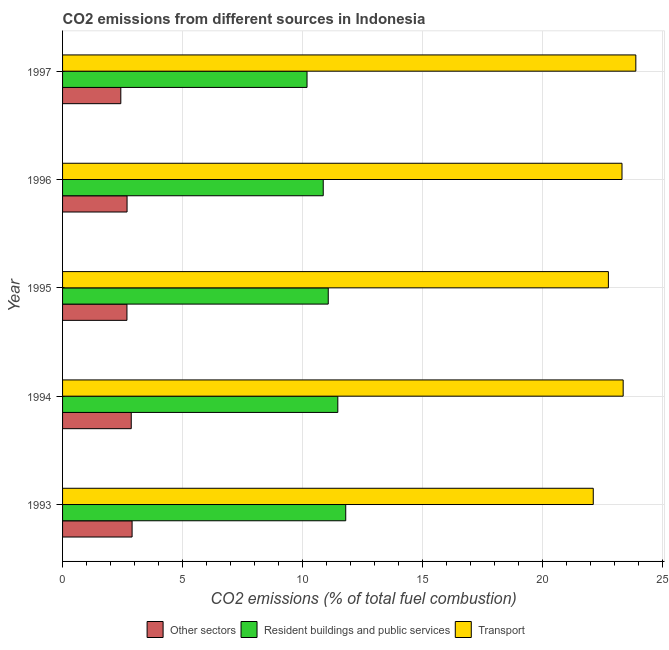How many different coloured bars are there?
Keep it short and to the point. 3. Are the number of bars per tick equal to the number of legend labels?
Provide a short and direct response. Yes. How many bars are there on the 2nd tick from the top?
Provide a short and direct response. 3. How many bars are there on the 4th tick from the bottom?
Offer a very short reply. 3. What is the label of the 5th group of bars from the top?
Offer a very short reply. 1993. What is the percentage of co2 emissions from resident buildings and public services in 1995?
Your response must be concise. 11.07. Across all years, what is the maximum percentage of co2 emissions from transport?
Keep it short and to the point. 23.88. Across all years, what is the minimum percentage of co2 emissions from transport?
Offer a very short reply. 22.11. What is the total percentage of co2 emissions from other sectors in the graph?
Keep it short and to the point. 13.55. What is the difference between the percentage of co2 emissions from transport in 1993 and that in 1995?
Give a very brief answer. -0.63. What is the difference between the percentage of co2 emissions from transport in 1994 and the percentage of co2 emissions from other sectors in 1996?
Offer a terse response. 20.67. What is the average percentage of co2 emissions from transport per year?
Offer a very short reply. 23.08. In the year 1995, what is the difference between the percentage of co2 emissions from resident buildings and public services and percentage of co2 emissions from transport?
Offer a terse response. -11.67. In how many years, is the percentage of co2 emissions from transport greater than 15 %?
Give a very brief answer. 5. What is the ratio of the percentage of co2 emissions from other sectors in 1995 to that in 1996?
Give a very brief answer. 1. Is the difference between the percentage of co2 emissions from transport in 1995 and 1997 greater than the difference between the percentage of co2 emissions from other sectors in 1995 and 1997?
Offer a very short reply. No. What is the difference between the highest and the second highest percentage of co2 emissions from other sectors?
Provide a succinct answer. 0.04. What is the difference between the highest and the lowest percentage of co2 emissions from resident buildings and public services?
Offer a terse response. 1.61. What does the 1st bar from the top in 1993 represents?
Give a very brief answer. Transport. What does the 2nd bar from the bottom in 1997 represents?
Your answer should be compact. Resident buildings and public services. Is it the case that in every year, the sum of the percentage of co2 emissions from other sectors and percentage of co2 emissions from resident buildings and public services is greater than the percentage of co2 emissions from transport?
Offer a very short reply. No. Are all the bars in the graph horizontal?
Offer a terse response. Yes. What is the difference between two consecutive major ticks on the X-axis?
Provide a succinct answer. 5. Does the graph contain any zero values?
Offer a very short reply. No. Where does the legend appear in the graph?
Keep it short and to the point. Bottom center. How many legend labels are there?
Provide a succinct answer. 3. What is the title of the graph?
Your response must be concise. CO2 emissions from different sources in Indonesia. What is the label or title of the X-axis?
Give a very brief answer. CO2 emissions (% of total fuel combustion). What is the CO2 emissions (% of total fuel combustion) in Other sectors in 1993?
Give a very brief answer. 2.9. What is the CO2 emissions (% of total fuel combustion) of Resident buildings and public services in 1993?
Offer a very short reply. 11.8. What is the CO2 emissions (% of total fuel combustion) of Transport in 1993?
Provide a succinct answer. 22.11. What is the CO2 emissions (% of total fuel combustion) of Other sectors in 1994?
Your answer should be very brief. 2.86. What is the CO2 emissions (% of total fuel combustion) of Resident buildings and public services in 1994?
Make the answer very short. 11.47. What is the CO2 emissions (% of total fuel combustion) in Transport in 1994?
Your answer should be very brief. 23.36. What is the CO2 emissions (% of total fuel combustion) of Other sectors in 1995?
Your response must be concise. 2.68. What is the CO2 emissions (% of total fuel combustion) of Resident buildings and public services in 1995?
Your answer should be very brief. 11.07. What is the CO2 emissions (% of total fuel combustion) in Transport in 1995?
Keep it short and to the point. 22.74. What is the CO2 emissions (% of total fuel combustion) of Other sectors in 1996?
Provide a short and direct response. 2.69. What is the CO2 emissions (% of total fuel combustion) of Resident buildings and public services in 1996?
Ensure brevity in your answer.  10.86. What is the CO2 emissions (% of total fuel combustion) in Transport in 1996?
Offer a very short reply. 23.31. What is the CO2 emissions (% of total fuel combustion) in Other sectors in 1997?
Provide a short and direct response. 2.43. What is the CO2 emissions (% of total fuel combustion) of Resident buildings and public services in 1997?
Your answer should be compact. 10.19. What is the CO2 emissions (% of total fuel combustion) in Transport in 1997?
Your answer should be compact. 23.88. Across all years, what is the maximum CO2 emissions (% of total fuel combustion) in Other sectors?
Provide a short and direct response. 2.9. Across all years, what is the maximum CO2 emissions (% of total fuel combustion) in Resident buildings and public services?
Keep it short and to the point. 11.8. Across all years, what is the maximum CO2 emissions (% of total fuel combustion) in Transport?
Your answer should be very brief. 23.88. Across all years, what is the minimum CO2 emissions (% of total fuel combustion) in Other sectors?
Your response must be concise. 2.43. Across all years, what is the minimum CO2 emissions (% of total fuel combustion) in Resident buildings and public services?
Offer a terse response. 10.19. Across all years, what is the minimum CO2 emissions (% of total fuel combustion) in Transport?
Provide a short and direct response. 22.11. What is the total CO2 emissions (% of total fuel combustion) in Other sectors in the graph?
Ensure brevity in your answer.  13.55. What is the total CO2 emissions (% of total fuel combustion) in Resident buildings and public services in the graph?
Make the answer very short. 55.38. What is the total CO2 emissions (% of total fuel combustion) of Transport in the graph?
Your answer should be very brief. 115.4. What is the difference between the CO2 emissions (% of total fuel combustion) in Other sectors in 1993 and that in 1994?
Provide a succinct answer. 0.04. What is the difference between the CO2 emissions (% of total fuel combustion) in Resident buildings and public services in 1993 and that in 1994?
Make the answer very short. 0.33. What is the difference between the CO2 emissions (% of total fuel combustion) of Transport in 1993 and that in 1994?
Offer a terse response. -1.25. What is the difference between the CO2 emissions (% of total fuel combustion) in Other sectors in 1993 and that in 1995?
Ensure brevity in your answer.  0.21. What is the difference between the CO2 emissions (% of total fuel combustion) of Resident buildings and public services in 1993 and that in 1995?
Provide a short and direct response. 0.73. What is the difference between the CO2 emissions (% of total fuel combustion) of Transport in 1993 and that in 1995?
Your response must be concise. -0.63. What is the difference between the CO2 emissions (% of total fuel combustion) of Other sectors in 1993 and that in 1996?
Provide a short and direct response. 0.21. What is the difference between the CO2 emissions (% of total fuel combustion) of Resident buildings and public services in 1993 and that in 1996?
Offer a terse response. 0.94. What is the difference between the CO2 emissions (% of total fuel combustion) in Transport in 1993 and that in 1996?
Your answer should be compact. -1.2. What is the difference between the CO2 emissions (% of total fuel combustion) in Other sectors in 1993 and that in 1997?
Ensure brevity in your answer.  0.47. What is the difference between the CO2 emissions (% of total fuel combustion) in Resident buildings and public services in 1993 and that in 1997?
Give a very brief answer. 1.61. What is the difference between the CO2 emissions (% of total fuel combustion) of Transport in 1993 and that in 1997?
Keep it short and to the point. -1.77. What is the difference between the CO2 emissions (% of total fuel combustion) of Other sectors in 1994 and that in 1995?
Your response must be concise. 0.18. What is the difference between the CO2 emissions (% of total fuel combustion) of Resident buildings and public services in 1994 and that in 1995?
Ensure brevity in your answer.  0.4. What is the difference between the CO2 emissions (% of total fuel combustion) of Transport in 1994 and that in 1995?
Ensure brevity in your answer.  0.62. What is the difference between the CO2 emissions (% of total fuel combustion) of Other sectors in 1994 and that in 1996?
Give a very brief answer. 0.17. What is the difference between the CO2 emissions (% of total fuel combustion) of Resident buildings and public services in 1994 and that in 1996?
Give a very brief answer. 0.61. What is the difference between the CO2 emissions (% of total fuel combustion) of Transport in 1994 and that in 1996?
Offer a terse response. 0.05. What is the difference between the CO2 emissions (% of total fuel combustion) in Other sectors in 1994 and that in 1997?
Ensure brevity in your answer.  0.43. What is the difference between the CO2 emissions (% of total fuel combustion) of Resident buildings and public services in 1994 and that in 1997?
Give a very brief answer. 1.28. What is the difference between the CO2 emissions (% of total fuel combustion) of Transport in 1994 and that in 1997?
Provide a short and direct response. -0.53. What is the difference between the CO2 emissions (% of total fuel combustion) of Other sectors in 1995 and that in 1996?
Your answer should be very brief. -0. What is the difference between the CO2 emissions (% of total fuel combustion) in Resident buildings and public services in 1995 and that in 1996?
Ensure brevity in your answer.  0.21. What is the difference between the CO2 emissions (% of total fuel combustion) of Transport in 1995 and that in 1996?
Provide a short and direct response. -0.57. What is the difference between the CO2 emissions (% of total fuel combustion) of Other sectors in 1995 and that in 1997?
Your answer should be very brief. 0.26. What is the difference between the CO2 emissions (% of total fuel combustion) in Resident buildings and public services in 1995 and that in 1997?
Keep it short and to the point. 0.88. What is the difference between the CO2 emissions (% of total fuel combustion) of Transport in 1995 and that in 1997?
Give a very brief answer. -1.14. What is the difference between the CO2 emissions (% of total fuel combustion) of Other sectors in 1996 and that in 1997?
Keep it short and to the point. 0.26. What is the difference between the CO2 emissions (% of total fuel combustion) of Resident buildings and public services in 1996 and that in 1997?
Provide a short and direct response. 0.68. What is the difference between the CO2 emissions (% of total fuel combustion) of Transport in 1996 and that in 1997?
Your answer should be compact. -0.58. What is the difference between the CO2 emissions (% of total fuel combustion) in Other sectors in 1993 and the CO2 emissions (% of total fuel combustion) in Resident buildings and public services in 1994?
Your answer should be compact. -8.57. What is the difference between the CO2 emissions (% of total fuel combustion) of Other sectors in 1993 and the CO2 emissions (% of total fuel combustion) of Transport in 1994?
Provide a short and direct response. -20.46. What is the difference between the CO2 emissions (% of total fuel combustion) in Resident buildings and public services in 1993 and the CO2 emissions (% of total fuel combustion) in Transport in 1994?
Your response must be concise. -11.56. What is the difference between the CO2 emissions (% of total fuel combustion) in Other sectors in 1993 and the CO2 emissions (% of total fuel combustion) in Resident buildings and public services in 1995?
Offer a terse response. -8.17. What is the difference between the CO2 emissions (% of total fuel combustion) of Other sectors in 1993 and the CO2 emissions (% of total fuel combustion) of Transport in 1995?
Offer a very short reply. -19.84. What is the difference between the CO2 emissions (% of total fuel combustion) of Resident buildings and public services in 1993 and the CO2 emissions (% of total fuel combustion) of Transport in 1995?
Give a very brief answer. -10.94. What is the difference between the CO2 emissions (% of total fuel combustion) in Other sectors in 1993 and the CO2 emissions (% of total fuel combustion) in Resident buildings and public services in 1996?
Offer a very short reply. -7.96. What is the difference between the CO2 emissions (% of total fuel combustion) in Other sectors in 1993 and the CO2 emissions (% of total fuel combustion) in Transport in 1996?
Your response must be concise. -20.41. What is the difference between the CO2 emissions (% of total fuel combustion) in Resident buildings and public services in 1993 and the CO2 emissions (% of total fuel combustion) in Transport in 1996?
Offer a very short reply. -11.51. What is the difference between the CO2 emissions (% of total fuel combustion) of Other sectors in 1993 and the CO2 emissions (% of total fuel combustion) of Resident buildings and public services in 1997?
Offer a very short reply. -7.29. What is the difference between the CO2 emissions (% of total fuel combustion) of Other sectors in 1993 and the CO2 emissions (% of total fuel combustion) of Transport in 1997?
Ensure brevity in your answer.  -20.99. What is the difference between the CO2 emissions (% of total fuel combustion) in Resident buildings and public services in 1993 and the CO2 emissions (% of total fuel combustion) in Transport in 1997?
Your answer should be very brief. -12.09. What is the difference between the CO2 emissions (% of total fuel combustion) in Other sectors in 1994 and the CO2 emissions (% of total fuel combustion) in Resident buildings and public services in 1995?
Offer a terse response. -8.21. What is the difference between the CO2 emissions (% of total fuel combustion) in Other sectors in 1994 and the CO2 emissions (% of total fuel combustion) in Transport in 1995?
Make the answer very short. -19.88. What is the difference between the CO2 emissions (% of total fuel combustion) in Resident buildings and public services in 1994 and the CO2 emissions (% of total fuel combustion) in Transport in 1995?
Your answer should be compact. -11.27. What is the difference between the CO2 emissions (% of total fuel combustion) of Other sectors in 1994 and the CO2 emissions (% of total fuel combustion) of Resident buildings and public services in 1996?
Provide a short and direct response. -8. What is the difference between the CO2 emissions (% of total fuel combustion) in Other sectors in 1994 and the CO2 emissions (% of total fuel combustion) in Transport in 1996?
Your answer should be very brief. -20.45. What is the difference between the CO2 emissions (% of total fuel combustion) in Resident buildings and public services in 1994 and the CO2 emissions (% of total fuel combustion) in Transport in 1996?
Offer a very short reply. -11.84. What is the difference between the CO2 emissions (% of total fuel combustion) in Other sectors in 1994 and the CO2 emissions (% of total fuel combustion) in Resident buildings and public services in 1997?
Your response must be concise. -7.32. What is the difference between the CO2 emissions (% of total fuel combustion) in Other sectors in 1994 and the CO2 emissions (% of total fuel combustion) in Transport in 1997?
Ensure brevity in your answer.  -21.02. What is the difference between the CO2 emissions (% of total fuel combustion) in Resident buildings and public services in 1994 and the CO2 emissions (% of total fuel combustion) in Transport in 1997?
Make the answer very short. -12.42. What is the difference between the CO2 emissions (% of total fuel combustion) in Other sectors in 1995 and the CO2 emissions (% of total fuel combustion) in Resident buildings and public services in 1996?
Your response must be concise. -8.18. What is the difference between the CO2 emissions (% of total fuel combustion) in Other sectors in 1995 and the CO2 emissions (% of total fuel combustion) in Transport in 1996?
Provide a succinct answer. -20.62. What is the difference between the CO2 emissions (% of total fuel combustion) of Resident buildings and public services in 1995 and the CO2 emissions (% of total fuel combustion) of Transport in 1996?
Keep it short and to the point. -12.24. What is the difference between the CO2 emissions (% of total fuel combustion) of Other sectors in 1995 and the CO2 emissions (% of total fuel combustion) of Resident buildings and public services in 1997?
Your answer should be very brief. -7.5. What is the difference between the CO2 emissions (% of total fuel combustion) of Other sectors in 1995 and the CO2 emissions (% of total fuel combustion) of Transport in 1997?
Provide a short and direct response. -21.2. What is the difference between the CO2 emissions (% of total fuel combustion) in Resident buildings and public services in 1995 and the CO2 emissions (% of total fuel combustion) in Transport in 1997?
Offer a terse response. -12.81. What is the difference between the CO2 emissions (% of total fuel combustion) in Other sectors in 1996 and the CO2 emissions (% of total fuel combustion) in Resident buildings and public services in 1997?
Your response must be concise. -7.5. What is the difference between the CO2 emissions (% of total fuel combustion) in Other sectors in 1996 and the CO2 emissions (% of total fuel combustion) in Transport in 1997?
Provide a short and direct response. -21.2. What is the difference between the CO2 emissions (% of total fuel combustion) of Resident buildings and public services in 1996 and the CO2 emissions (% of total fuel combustion) of Transport in 1997?
Give a very brief answer. -13.02. What is the average CO2 emissions (% of total fuel combustion) in Other sectors per year?
Offer a terse response. 2.71. What is the average CO2 emissions (% of total fuel combustion) of Resident buildings and public services per year?
Your answer should be very brief. 11.08. What is the average CO2 emissions (% of total fuel combustion) of Transport per year?
Offer a terse response. 23.08. In the year 1993, what is the difference between the CO2 emissions (% of total fuel combustion) in Other sectors and CO2 emissions (% of total fuel combustion) in Resident buildings and public services?
Provide a succinct answer. -8.9. In the year 1993, what is the difference between the CO2 emissions (% of total fuel combustion) of Other sectors and CO2 emissions (% of total fuel combustion) of Transport?
Keep it short and to the point. -19.21. In the year 1993, what is the difference between the CO2 emissions (% of total fuel combustion) of Resident buildings and public services and CO2 emissions (% of total fuel combustion) of Transport?
Make the answer very short. -10.31. In the year 1994, what is the difference between the CO2 emissions (% of total fuel combustion) in Other sectors and CO2 emissions (% of total fuel combustion) in Resident buildings and public services?
Your answer should be very brief. -8.61. In the year 1994, what is the difference between the CO2 emissions (% of total fuel combustion) in Other sectors and CO2 emissions (% of total fuel combustion) in Transport?
Offer a terse response. -20.49. In the year 1994, what is the difference between the CO2 emissions (% of total fuel combustion) of Resident buildings and public services and CO2 emissions (% of total fuel combustion) of Transport?
Keep it short and to the point. -11.89. In the year 1995, what is the difference between the CO2 emissions (% of total fuel combustion) in Other sectors and CO2 emissions (% of total fuel combustion) in Resident buildings and public services?
Your response must be concise. -8.39. In the year 1995, what is the difference between the CO2 emissions (% of total fuel combustion) of Other sectors and CO2 emissions (% of total fuel combustion) of Transport?
Give a very brief answer. -20.06. In the year 1995, what is the difference between the CO2 emissions (% of total fuel combustion) in Resident buildings and public services and CO2 emissions (% of total fuel combustion) in Transport?
Your answer should be very brief. -11.67. In the year 1996, what is the difference between the CO2 emissions (% of total fuel combustion) in Other sectors and CO2 emissions (% of total fuel combustion) in Resident buildings and public services?
Provide a short and direct response. -8.17. In the year 1996, what is the difference between the CO2 emissions (% of total fuel combustion) in Other sectors and CO2 emissions (% of total fuel combustion) in Transport?
Keep it short and to the point. -20.62. In the year 1996, what is the difference between the CO2 emissions (% of total fuel combustion) of Resident buildings and public services and CO2 emissions (% of total fuel combustion) of Transport?
Give a very brief answer. -12.45. In the year 1997, what is the difference between the CO2 emissions (% of total fuel combustion) in Other sectors and CO2 emissions (% of total fuel combustion) in Resident buildings and public services?
Your answer should be compact. -7.76. In the year 1997, what is the difference between the CO2 emissions (% of total fuel combustion) in Other sectors and CO2 emissions (% of total fuel combustion) in Transport?
Offer a very short reply. -21.46. In the year 1997, what is the difference between the CO2 emissions (% of total fuel combustion) in Resident buildings and public services and CO2 emissions (% of total fuel combustion) in Transport?
Provide a succinct answer. -13.7. What is the ratio of the CO2 emissions (% of total fuel combustion) of Other sectors in 1993 to that in 1994?
Offer a terse response. 1.01. What is the ratio of the CO2 emissions (% of total fuel combustion) of Resident buildings and public services in 1993 to that in 1994?
Make the answer very short. 1.03. What is the ratio of the CO2 emissions (% of total fuel combustion) in Transport in 1993 to that in 1994?
Your answer should be compact. 0.95. What is the ratio of the CO2 emissions (% of total fuel combustion) of Other sectors in 1993 to that in 1995?
Provide a short and direct response. 1.08. What is the ratio of the CO2 emissions (% of total fuel combustion) of Resident buildings and public services in 1993 to that in 1995?
Provide a succinct answer. 1.07. What is the ratio of the CO2 emissions (% of total fuel combustion) in Transport in 1993 to that in 1995?
Ensure brevity in your answer.  0.97. What is the ratio of the CO2 emissions (% of total fuel combustion) of Other sectors in 1993 to that in 1996?
Offer a very short reply. 1.08. What is the ratio of the CO2 emissions (% of total fuel combustion) of Resident buildings and public services in 1993 to that in 1996?
Your answer should be compact. 1.09. What is the ratio of the CO2 emissions (% of total fuel combustion) of Transport in 1993 to that in 1996?
Provide a short and direct response. 0.95. What is the ratio of the CO2 emissions (% of total fuel combustion) of Other sectors in 1993 to that in 1997?
Your answer should be very brief. 1.19. What is the ratio of the CO2 emissions (% of total fuel combustion) of Resident buildings and public services in 1993 to that in 1997?
Your answer should be very brief. 1.16. What is the ratio of the CO2 emissions (% of total fuel combustion) in Transport in 1993 to that in 1997?
Ensure brevity in your answer.  0.93. What is the ratio of the CO2 emissions (% of total fuel combustion) in Other sectors in 1994 to that in 1995?
Ensure brevity in your answer.  1.07. What is the ratio of the CO2 emissions (% of total fuel combustion) in Resident buildings and public services in 1994 to that in 1995?
Your response must be concise. 1.04. What is the ratio of the CO2 emissions (% of total fuel combustion) in Transport in 1994 to that in 1995?
Keep it short and to the point. 1.03. What is the ratio of the CO2 emissions (% of total fuel combustion) in Other sectors in 1994 to that in 1996?
Offer a terse response. 1.06. What is the ratio of the CO2 emissions (% of total fuel combustion) in Resident buildings and public services in 1994 to that in 1996?
Keep it short and to the point. 1.06. What is the ratio of the CO2 emissions (% of total fuel combustion) in Other sectors in 1994 to that in 1997?
Offer a terse response. 1.18. What is the ratio of the CO2 emissions (% of total fuel combustion) of Resident buildings and public services in 1994 to that in 1997?
Give a very brief answer. 1.13. What is the ratio of the CO2 emissions (% of total fuel combustion) in Transport in 1994 to that in 1997?
Your answer should be compact. 0.98. What is the ratio of the CO2 emissions (% of total fuel combustion) in Other sectors in 1995 to that in 1996?
Ensure brevity in your answer.  1. What is the ratio of the CO2 emissions (% of total fuel combustion) of Resident buildings and public services in 1995 to that in 1996?
Your answer should be compact. 1.02. What is the ratio of the CO2 emissions (% of total fuel combustion) of Transport in 1995 to that in 1996?
Your answer should be compact. 0.98. What is the ratio of the CO2 emissions (% of total fuel combustion) of Other sectors in 1995 to that in 1997?
Offer a very short reply. 1.11. What is the ratio of the CO2 emissions (% of total fuel combustion) of Resident buildings and public services in 1995 to that in 1997?
Offer a terse response. 1.09. What is the ratio of the CO2 emissions (% of total fuel combustion) in Transport in 1995 to that in 1997?
Your response must be concise. 0.95. What is the ratio of the CO2 emissions (% of total fuel combustion) of Other sectors in 1996 to that in 1997?
Your answer should be very brief. 1.11. What is the ratio of the CO2 emissions (% of total fuel combustion) of Resident buildings and public services in 1996 to that in 1997?
Your answer should be very brief. 1.07. What is the ratio of the CO2 emissions (% of total fuel combustion) of Transport in 1996 to that in 1997?
Make the answer very short. 0.98. What is the difference between the highest and the second highest CO2 emissions (% of total fuel combustion) in Other sectors?
Give a very brief answer. 0.04. What is the difference between the highest and the second highest CO2 emissions (% of total fuel combustion) of Resident buildings and public services?
Make the answer very short. 0.33. What is the difference between the highest and the second highest CO2 emissions (% of total fuel combustion) in Transport?
Your answer should be compact. 0.53. What is the difference between the highest and the lowest CO2 emissions (% of total fuel combustion) of Other sectors?
Your answer should be very brief. 0.47. What is the difference between the highest and the lowest CO2 emissions (% of total fuel combustion) of Resident buildings and public services?
Provide a short and direct response. 1.61. What is the difference between the highest and the lowest CO2 emissions (% of total fuel combustion) of Transport?
Your answer should be compact. 1.77. 